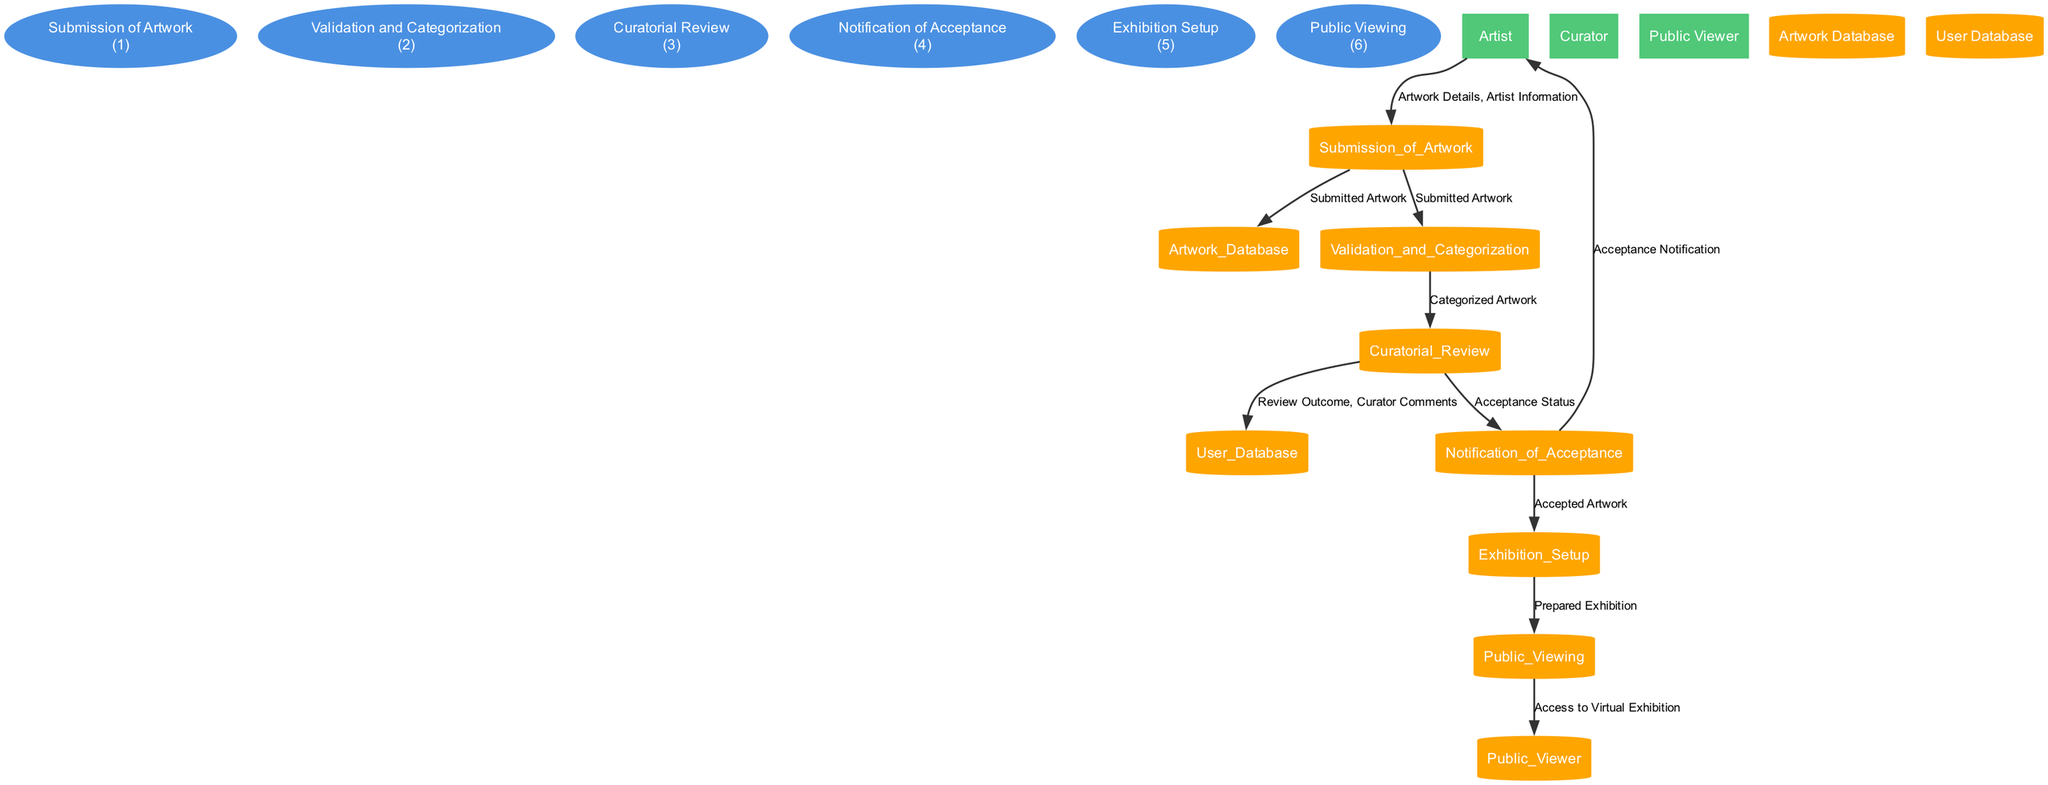What is the first process in the diagram? The first process listed in the data is the "Submission of Artwork," which involves artists submitting their artwork through an online form. Therefore, this is identified as the starting point of the workflow in the diagram.
Answer: Submission of Artwork How many data stores are present in the diagram? According to the provided data, there are two data stores indicated: "Artwork Database" and "User Database." This provides insight into where information is stored within the system.
Answer: 2 Which external entity receives the acceptance notification? The external entity that receives the acceptance notification is the "Artist." This is explicit in the flow illustrating the communication in the diagram where acceptance notifications are directed towards the artists.
Answer: Artist What type of information flows from "Curatorial Review" to "User Database"? The flow between "Curatorial Review" and "User Database" includes "Review Outcome" and "Curator Comments." This indicates that the results of the review process along with comments from curators are documented in the user database for future reference.
Answer: Review Outcome, Curator Comments What process follows "Validation and Categorization"? Following "Validation and Categorization," the process that occurs is "Curatorial Review." This sequence shows how validated and categorized artwork is subsequently reviewed for selection into the exhibition.
Answer: Curatorial Review If an artist's artwork is accepted, what is the next process that occurs? If an artist's artwork is accepted, the next process is "Exhibition Setup." This indicates that accepted works are then prepared and arranged for presentation in the virtual exhibition that follows.
Answer: Exhibition Setup What does the "Public Viewing" process provide to its external entity? The "Public Viewing" process provides "Access to Virtual Exhibition" to the external entity known as the "Public Viewer." This means that the final stage facilitates the audience's ability to view the art exhibit online.
Answer: Access to Virtual Exhibition How many total processes are involved in the online artwork submission workflow? The diagram includes a total of six processes detailing various stages of the artwork submission workflow. This enumeration helps understand the sequential operations involved from submission to public viewing.
Answer: 6 